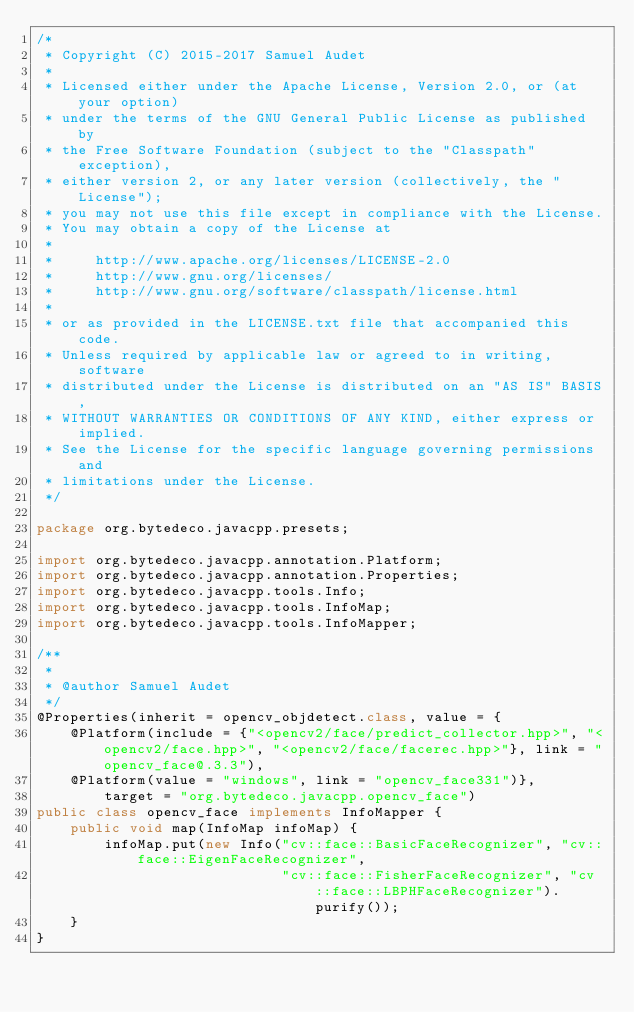<code> <loc_0><loc_0><loc_500><loc_500><_Java_>/*
 * Copyright (C) 2015-2017 Samuel Audet
 *
 * Licensed either under the Apache License, Version 2.0, or (at your option)
 * under the terms of the GNU General Public License as published by
 * the Free Software Foundation (subject to the "Classpath" exception),
 * either version 2, or any later version (collectively, the "License");
 * you may not use this file except in compliance with the License.
 * You may obtain a copy of the License at
 *
 *     http://www.apache.org/licenses/LICENSE-2.0
 *     http://www.gnu.org/licenses/
 *     http://www.gnu.org/software/classpath/license.html
 *
 * or as provided in the LICENSE.txt file that accompanied this code.
 * Unless required by applicable law or agreed to in writing, software
 * distributed under the License is distributed on an "AS IS" BASIS,
 * WITHOUT WARRANTIES OR CONDITIONS OF ANY KIND, either express or implied.
 * See the License for the specific language governing permissions and
 * limitations under the License.
 */

package org.bytedeco.javacpp.presets;

import org.bytedeco.javacpp.annotation.Platform;
import org.bytedeco.javacpp.annotation.Properties;
import org.bytedeco.javacpp.tools.Info;
import org.bytedeco.javacpp.tools.InfoMap;
import org.bytedeco.javacpp.tools.InfoMapper;

/**
 *
 * @author Samuel Audet
 */
@Properties(inherit = opencv_objdetect.class, value = {
    @Platform(include = {"<opencv2/face/predict_collector.hpp>", "<opencv2/face.hpp>", "<opencv2/face/facerec.hpp>"}, link = "opencv_face@.3.3"),
    @Platform(value = "windows", link = "opencv_face331")},
        target = "org.bytedeco.javacpp.opencv_face")
public class opencv_face implements InfoMapper {
    public void map(InfoMap infoMap) {
        infoMap.put(new Info("cv::face::BasicFaceRecognizer", "cv::face::EigenFaceRecognizer",
                             "cv::face::FisherFaceRecognizer", "cv::face::LBPHFaceRecognizer").purify());
    }
}
</code> 